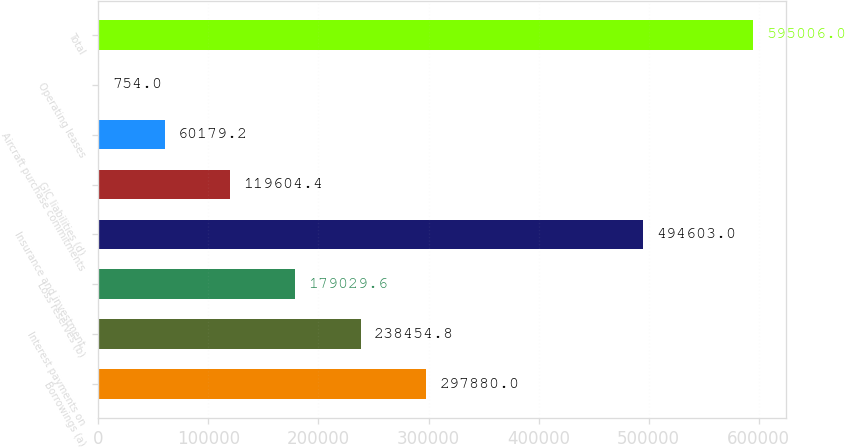Convert chart. <chart><loc_0><loc_0><loc_500><loc_500><bar_chart><fcel>Borrowings (a)<fcel>Interest payments on<fcel>Loss reserves (b)<fcel>Insurance and investment<fcel>GIC liabilities (d)<fcel>Aircraft purchase commitments<fcel>Operating leases<fcel>Total<nl><fcel>297880<fcel>238455<fcel>179030<fcel>494603<fcel>119604<fcel>60179.2<fcel>754<fcel>595006<nl></chart> 